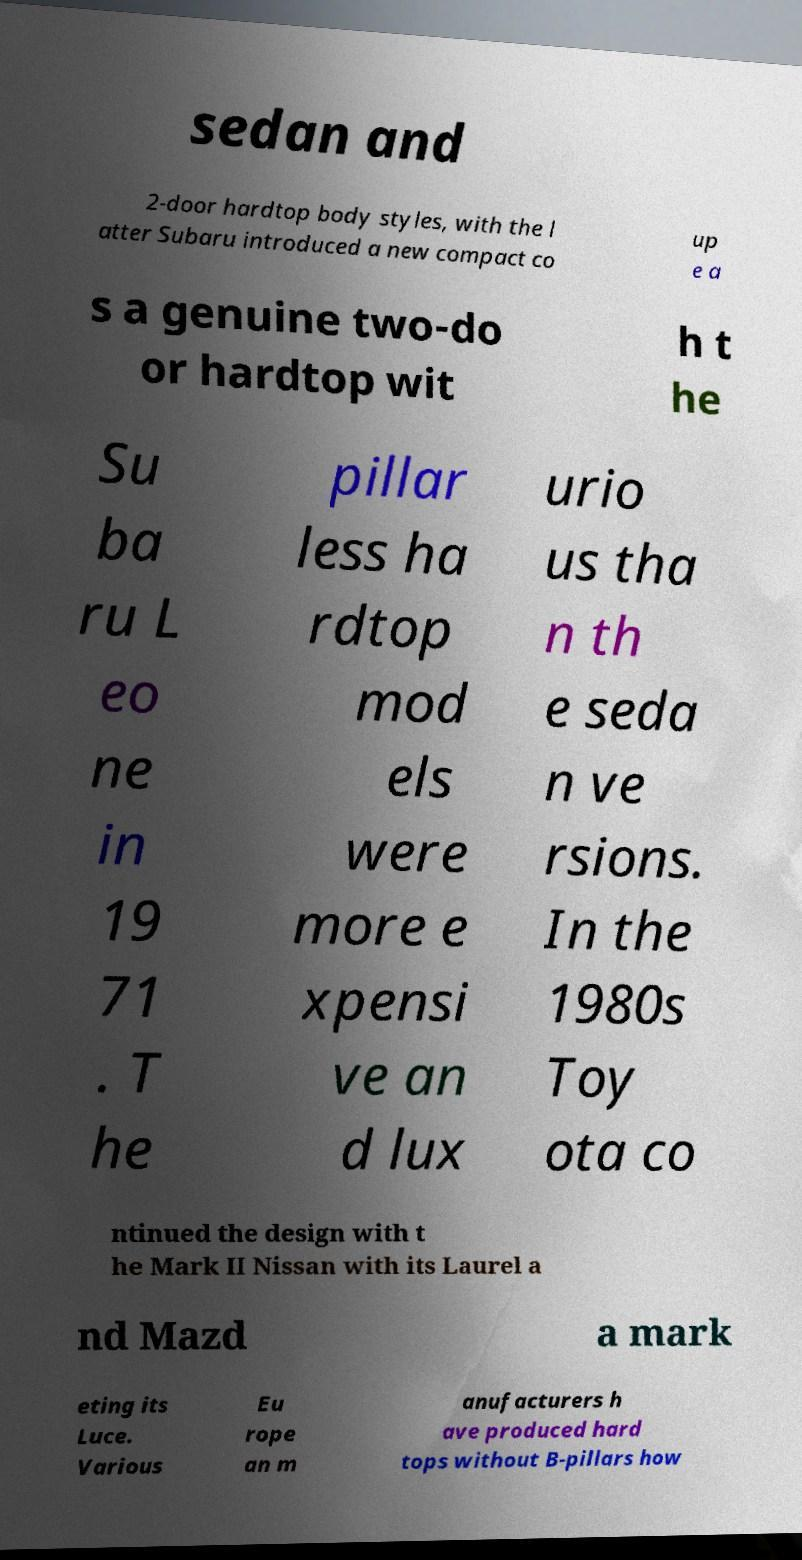Could you extract and type out the text from this image? sedan and 2-door hardtop body styles, with the l atter Subaru introduced a new compact co up e a s a genuine two-do or hardtop wit h t he Su ba ru L eo ne in 19 71 . T he pillar less ha rdtop mod els were more e xpensi ve an d lux urio us tha n th e seda n ve rsions. In the 1980s Toy ota co ntinued the design with t he Mark II Nissan with its Laurel a nd Mazd a mark eting its Luce. Various Eu rope an m anufacturers h ave produced hard tops without B-pillars how 